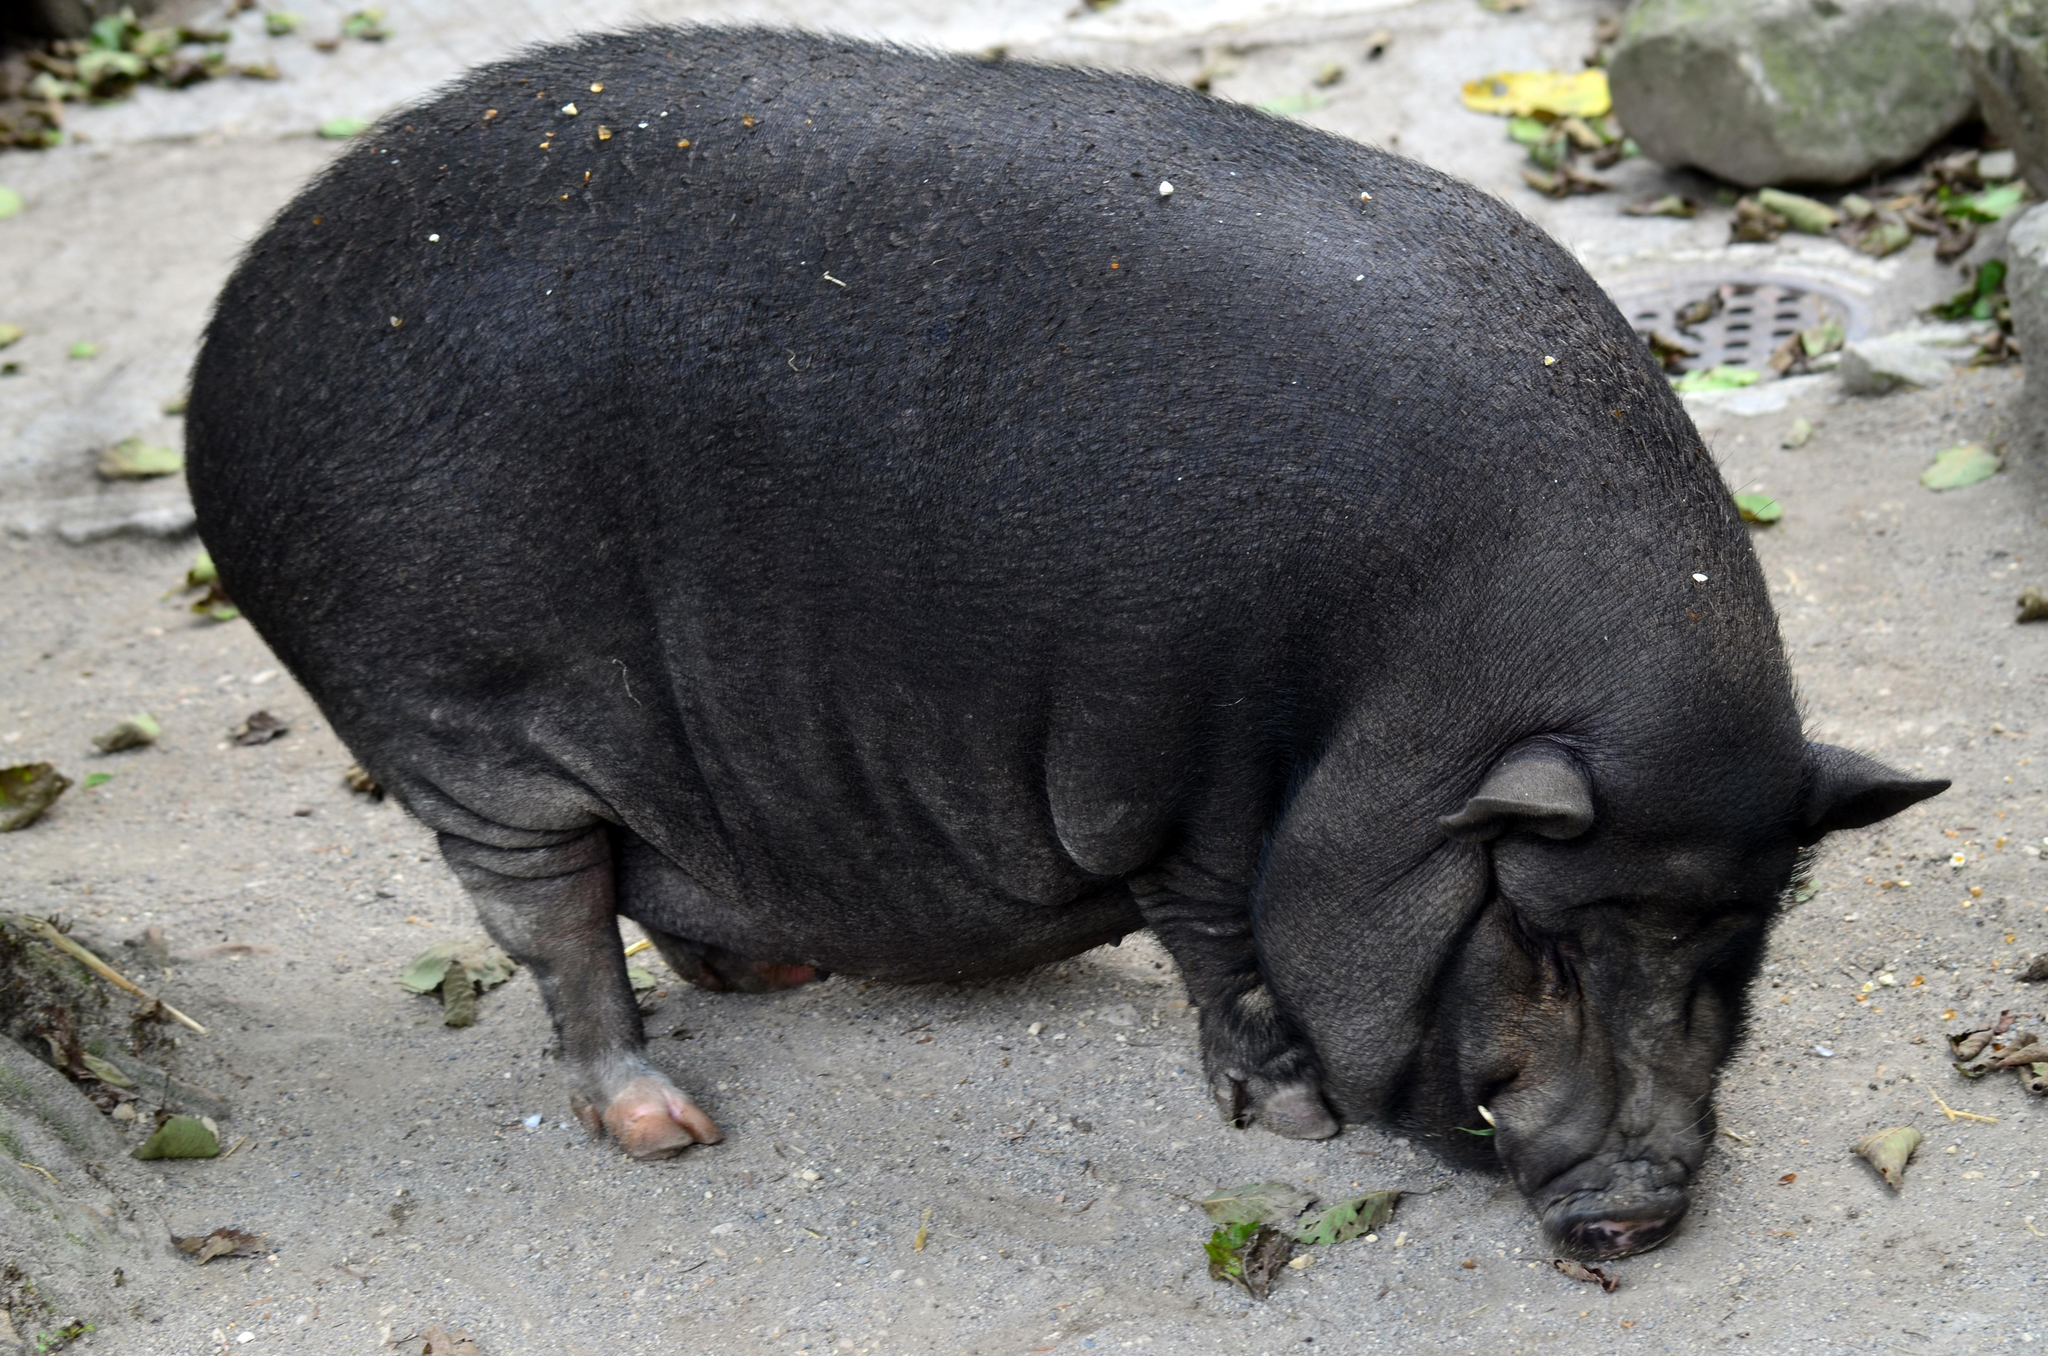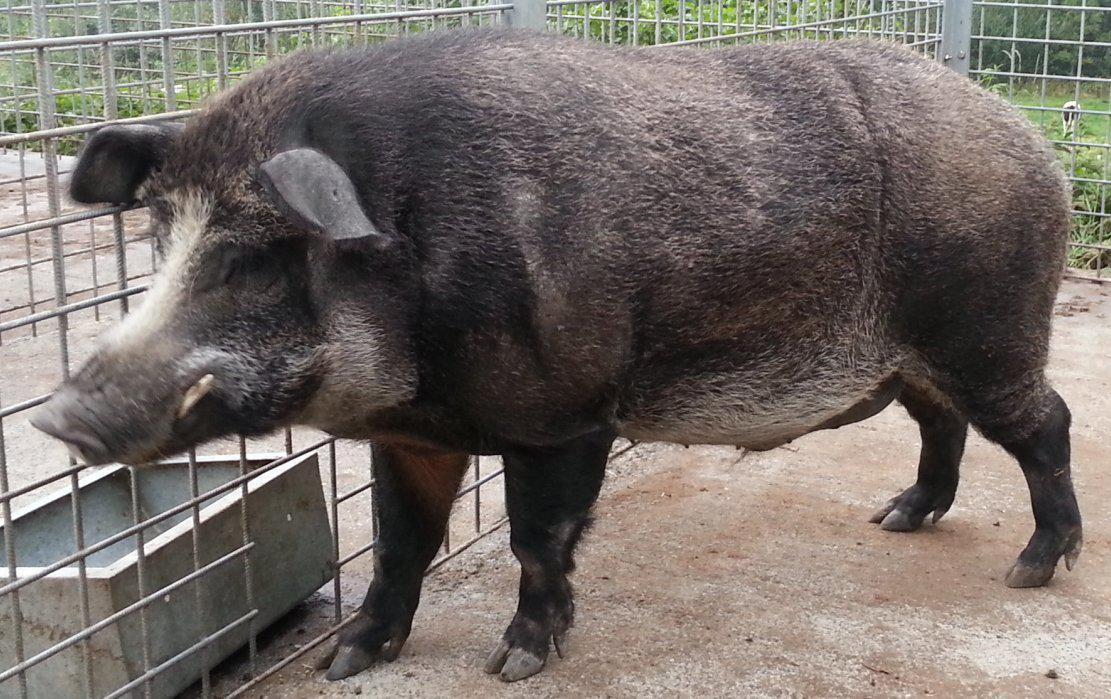The first image is the image on the left, the second image is the image on the right. Examine the images to the left and right. Is the description "The hog on the right image is standing and facing right" accurate? Answer yes or no. No. 